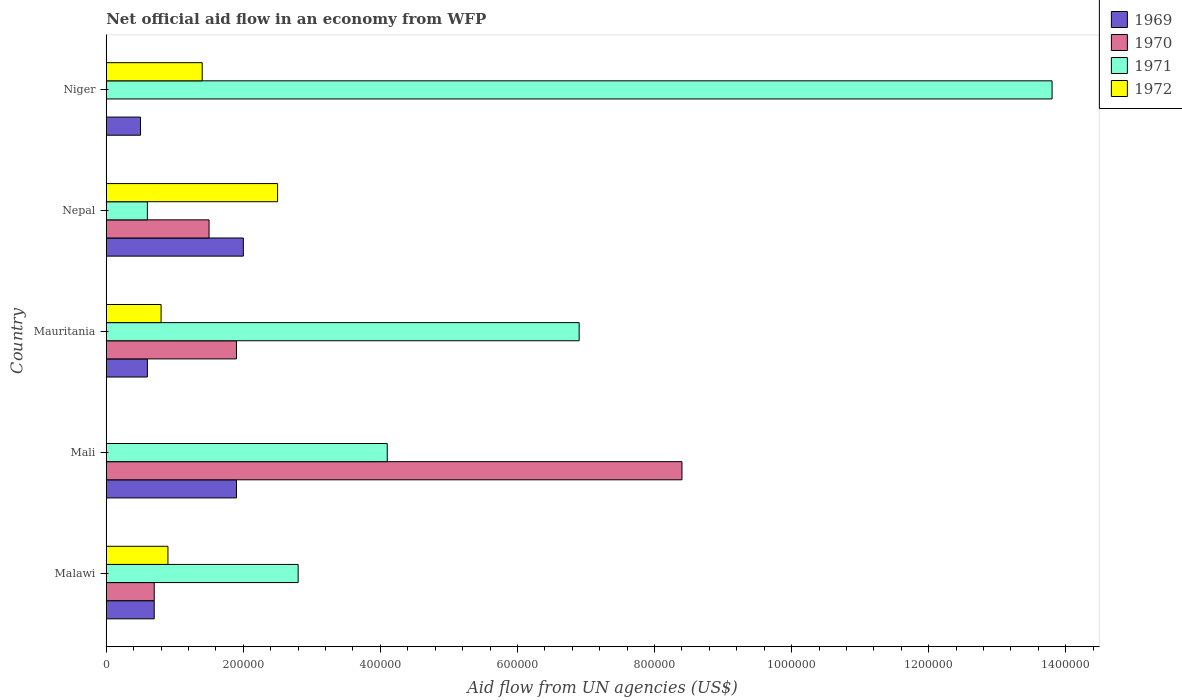How many different coloured bars are there?
Your answer should be very brief. 4. How many groups of bars are there?
Make the answer very short. 5. Are the number of bars per tick equal to the number of legend labels?
Your response must be concise. No. How many bars are there on the 3rd tick from the top?
Provide a succinct answer. 4. How many bars are there on the 3rd tick from the bottom?
Ensure brevity in your answer.  4. What is the label of the 4th group of bars from the top?
Offer a terse response. Mali. In how many cases, is the number of bars for a given country not equal to the number of legend labels?
Provide a short and direct response. 2. Across all countries, what is the maximum net official aid flow in 1971?
Provide a succinct answer. 1.38e+06. Across all countries, what is the minimum net official aid flow in 1972?
Your answer should be very brief. 0. In which country was the net official aid flow in 1970 maximum?
Your response must be concise. Mali. What is the total net official aid flow in 1969 in the graph?
Ensure brevity in your answer.  5.70e+05. What is the difference between the net official aid flow in 1971 in Malawi and that in Niger?
Ensure brevity in your answer.  -1.10e+06. What is the difference between the net official aid flow in 1972 in Mauritania and the net official aid flow in 1969 in Malawi?
Keep it short and to the point. 10000. What is the difference between the net official aid flow in 1970 and net official aid flow in 1972 in Mauritania?
Your response must be concise. 1.10e+05. In how many countries, is the net official aid flow in 1970 greater than 880000 US$?
Make the answer very short. 0. What is the ratio of the net official aid flow in 1971 in Malawi to that in Mali?
Ensure brevity in your answer.  0.68. Is the net official aid flow in 1971 in Mali less than that in Nepal?
Provide a short and direct response. No. What is the difference between the highest and the second highest net official aid flow in 1971?
Your answer should be compact. 6.90e+05. What is the difference between the highest and the lowest net official aid flow in 1970?
Offer a terse response. 8.40e+05. Is the sum of the net official aid flow in 1971 in Mauritania and Nepal greater than the maximum net official aid flow in 1972 across all countries?
Offer a terse response. Yes. Is it the case that in every country, the sum of the net official aid flow in 1971 and net official aid flow in 1970 is greater than the sum of net official aid flow in 1972 and net official aid flow in 1969?
Give a very brief answer. No. How many bars are there?
Ensure brevity in your answer.  18. Are all the bars in the graph horizontal?
Ensure brevity in your answer.  Yes. How many countries are there in the graph?
Give a very brief answer. 5. What is the title of the graph?
Your answer should be compact. Net official aid flow in an economy from WFP. Does "1962" appear as one of the legend labels in the graph?
Ensure brevity in your answer.  No. What is the label or title of the X-axis?
Make the answer very short. Aid flow from UN agencies (US$). What is the Aid flow from UN agencies (US$) of 1969 in Malawi?
Provide a succinct answer. 7.00e+04. What is the Aid flow from UN agencies (US$) of 1971 in Malawi?
Ensure brevity in your answer.  2.80e+05. What is the Aid flow from UN agencies (US$) of 1972 in Malawi?
Provide a succinct answer. 9.00e+04. What is the Aid flow from UN agencies (US$) of 1969 in Mali?
Offer a very short reply. 1.90e+05. What is the Aid flow from UN agencies (US$) in 1970 in Mali?
Make the answer very short. 8.40e+05. What is the Aid flow from UN agencies (US$) in 1971 in Mali?
Your response must be concise. 4.10e+05. What is the Aid flow from UN agencies (US$) in 1970 in Mauritania?
Keep it short and to the point. 1.90e+05. What is the Aid flow from UN agencies (US$) of 1971 in Mauritania?
Make the answer very short. 6.90e+05. What is the Aid flow from UN agencies (US$) in 1972 in Mauritania?
Make the answer very short. 8.00e+04. What is the Aid flow from UN agencies (US$) in 1969 in Nepal?
Give a very brief answer. 2.00e+05. What is the Aid flow from UN agencies (US$) in 1970 in Nepal?
Your answer should be very brief. 1.50e+05. What is the Aid flow from UN agencies (US$) in 1971 in Nepal?
Provide a succinct answer. 6.00e+04. What is the Aid flow from UN agencies (US$) of 1972 in Nepal?
Make the answer very short. 2.50e+05. What is the Aid flow from UN agencies (US$) in 1969 in Niger?
Offer a very short reply. 5.00e+04. What is the Aid flow from UN agencies (US$) of 1970 in Niger?
Offer a very short reply. 0. What is the Aid flow from UN agencies (US$) of 1971 in Niger?
Your answer should be compact. 1.38e+06. Across all countries, what is the maximum Aid flow from UN agencies (US$) of 1969?
Offer a terse response. 2.00e+05. Across all countries, what is the maximum Aid flow from UN agencies (US$) in 1970?
Your answer should be compact. 8.40e+05. Across all countries, what is the maximum Aid flow from UN agencies (US$) of 1971?
Give a very brief answer. 1.38e+06. Across all countries, what is the maximum Aid flow from UN agencies (US$) in 1972?
Give a very brief answer. 2.50e+05. What is the total Aid flow from UN agencies (US$) in 1969 in the graph?
Offer a terse response. 5.70e+05. What is the total Aid flow from UN agencies (US$) of 1970 in the graph?
Provide a short and direct response. 1.25e+06. What is the total Aid flow from UN agencies (US$) in 1971 in the graph?
Provide a short and direct response. 2.82e+06. What is the total Aid flow from UN agencies (US$) in 1972 in the graph?
Your answer should be compact. 5.60e+05. What is the difference between the Aid flow from UN agencies (US$) in 1970 in Malawi and that in Mali?
Offer a very short reply. -7.70e+05. What is the difference between the Aid flow from UN agencies (US$) in 1971 in Malawi and that in Mali?
Provide a succinct answer. -1.30e+05. What is the difference between the Aid flow from UN agencies (US$) in 1971 in Malawi and that in Mauritania?
Your answer should be very brief. -4.10e+05. What is the difference between the Aid flow from UN agencies (US$) of 1971 in Malawi and that in Nepal?
Provide a short and direct response. 2.20e+05. What is the difference between the Aid flow from UN agencies (US$) of 1969 in Malawi and that in Niger?
Your response must be concise. 2.00e+04. What is the difference between the Aid flow from UN agencies (US$) of 1971 in Malawi and that in Niger?
Your answer should be very brief. -1.10e+06. What is the difference between the Aid flow from UN agencies (US$) in 1970 in Mali and that in Mauritania?
Provide a succinct answer. 6.50e+05. What is the difference between the Aid flow from UN agencies (US$) of 1971 in Mali and that in Mauritania?
Make the answer very short. -2.80e+05. What is the difference between the Aid flow from UN agencies (US$) in 1970 in Mali and that in Nepal?
Your answer should be compact. 6.90e+05. What is the difference between the Aid flow from UN agencies (US$) of 1971 in Mali and that in Nepal?
Provide a short and direct response. 3.50e+05. What is the difference between the Aid flow from UN agencies (US$) in 1969 in Mali and that in Niger?
Your response must be concise. 1.40e+05. What is the difference between the Aid flow from UN agencies (US$) in 1971 in Mali and that in Niger?
Keep it short and to the point. -9.70e+05. What is the difference between the Aid flow from UN agencies (US$) in 1971 in Mauritania and that in Nepal?
Keep it short and to the point. 6.30e+05. What is the difference between the Aid flow from UN agencies (US$) in 1969 in Mauritania and that in Niger?
Your answer should be very brief. 10000. What is the difference between the Aid flow from UN agencies (US$) in 1971 in Mauritania and that in Niger?
Give a very brief answer. -6.90e+05. What is the difference between the Aid flow from UN agencies (US$) in 1972 in Mauritania and that in Niger?
Keep it short and to the point. -6.00e+04. What is the difference between the Aid flow from UN agencies (US$) in 1971 in Nepal and that in Niger?
Your answer should be very brief. -1.32e+06. What is the difference between the Aid flow from UN agencies (US$) of 1969 in Malawi and the Aid flow from UN agencies (US$) of 1970 in Mali?
Ensure brevity in your answer.  -7.70e+05. What is the difference between the Aid flow from UN agencies (US$) in 1969 in Malawi and the Aid flow from UN agencies (US$) in 1971 in Mali?
Your answer should be compact. -3.40e+05. What is the difference between the Aid flow from UN agencies (US$) in 1969 in Malawi and the Aid flow from UN agencies (US$) in 1971 in Mauritania?
Provide a short and direct response. -6.20e+05. What is the difference between the Aid flow from UN agencies (US$) of 1970 in Malawi and the Aid flow from UN agencies (US$) of 1971 in Mauritania?
Make the answer very short. -6.20e+05. What is the difference between the Aid flow from UN agencies (US$) in 1970 in Malawi and the Aid flow from UN agencies (US$) in 1972 in Mauritania?
Your answer should be compact. -10000. What is the difference between the Aid flow from UN agencies (US$) in 1969 in Malawi and the Aid flow from UN agencies (US$) in 1970 in Nepal?
Keep it short and to the point. -8.00e+04. What is the difference between the Aid flow from UN agencies (US$) of 1969 in Malawi and the Aid flow from UN agencies (US$) of 1971 in Nepal?
Provide a succinct answer. 10000. What is the difference between the Aid flow from UN agencies (US$) in 1970 in Malawi and the Aid flow from UN agencies (US$) in 1972 in Nepal?
Your answer should be very brief. -1.80e+05. What is the difference between the Aid flow from UN agencies (US$) of 1969 in Malawi and the Aid flow from UN agencies (US$) of 1971 in Niger?
Ensure brevity in your answer.  -1.31e+06. What is the difference between the Aid flow from UN agencies (US$) in 1969 in Malawi and the Aid flow from UN agencies (US$) in 1972 in Niger?
Give a very brief answer. -7.00e+04. What is the difference between the Aid flow from UN agencies (US$) in 1970 in Malawi and the Aid flow from UN agencies (US$) in 1971 in Niger?
Your answer should be very brief. -1.31e+06. What is the difference between the Aid flow from UN agencies (US$) in 1970 in Malawi and the Aid flow from UN agencies (US$) in 1972 in Niger?
Your answer should be compact. -7.00e+04. What is the difference between the Aid flow from UN agencies (US$) in 1969 in Mali and the Aid flow from UN agencies (US$) in 1970 in Mauritania?
Ensure brevity in your answer.  0. What is the difference between the Aid flow from UN agencies (US$) of 1969 in Mali and the Aid flow from UN agencies (US$) of 1971 in Mauritania?
Your response must be concise. -5.00e+05. What is the difference between the Aid flow from UN agencies (US$) of 1970 in Mali and the Aid flow from UN agencies (US$) of 1972 in Mauritania?
Offer a terse response. 7.60e+05. What is the difference between the Aid flow from UN agencies (US$) of 1969 in Mali and the Aid flow from UN agencies (US$) of 1970 in Nepal?
Provide a succinct answer. 4.00e+04. What is the difference between the Aid flow from UN agencies (US$) in 1969 in Mali and the Aid flow from UN agencies (US$) in 1971 in Nepal?
Your answer should be very brief. 1.30e+05. What is the difference between the Aid flow from UN agencies (US$) in 1970 in Mali and the Aid flow from UN agencies (US$) in 1971 in Nepal?
Keep it short and to the point. 7.80e+05. What is the difference between the Aid flow from UN agencies (US$) of 1970 in Mali and the Aid flow from UN agencies (US$) of 1972 in Nepal?
Offer a very short reply. 5.90e+05. What is the difference between the Aid flow from UN agencies (US$) in 1971 in Mali and the Aid flow from UN agencies (US$) in 1972 in Nepal?
Your response must be concise. 1.60e+05. What is the difference between the Aid flow from UN agencies (US$) in 1969 in Mali and the Aid flow from UN agencies (US$) in 1971 in Niger?
Your response must be concise. -1.19e+06. What is the difference between the Aid flow from UN agencies (US$) of 1970 in Mali and the Aid flow from UN agencies (US$) of 1971 in Niger?
Offer a very short reply. -5.40e+05. What is the difference between the Aid flow from UN agencies (US$) of 1970 in Mali and the Aid flow from UN agencies (US$) of 1972 in Niger?
Provide a short and direct response. 7.00e+05. What is the difference between the Aid flow from UN agencies (US$) in 1969 in Mauritania and the Aid flow from UN agencies (US$) in 1970 in Nepal?
Ensure brevity in your answer.  -9.00e+04. What is the difference between the Aid flow from UN agencies (US$) of 1969 in Mauritania and the Aid flow from UN agencies (US$) of 1971 in Nepal?
Your answer should be very brief. 0. What is the difference between the Aid flow from UN agencies (US$) in 1969 in Mauritania and the Aid flow from UN agencies (US$) in 1972 in Nepal?
Your answer should be compact. -1.90e+05. What is the difference between the Aid flow from UN agencies (US$) in 1970 in Mauritania and the Aid flow from UN agencies (US$) in 1972 in Nepal?
Offer a terse response. -6.00e+04. What is the difference between the Aid flow from UN agencies (US$) of 1969 in Mauritania and the Aid flow from UN agencies (US$) of 1971 in Niger?
Offer a very short reply. -1.32e+06. What is the difference between the Aid flow from UN agencies (US$) in 1969 in Mauritania and the Aid flow from UN agencies (US$) in 1972 in Niger?
Your response must be concise. -8.00e+04. What is the difference between the Aid flow from UN agencies (US$) in 1970 in Mauritania and the Aid flow from UN agencies (US$) in 1971 in Niger?
Your answer should be compact. -1.19e+06. What is the difference between the Aid flow from UN agencies (US$) of 1969 in Nepal and the Aid flow from UN agencies (US$) of 1971 in Niger?
Your response must be concise. -1.18e+06. What is the difference between the Aid flow from UN agencies (US$) of 1970 in Nepal and the Aid flow from UN agencies (US$) of 1971 in Niger?
Offer a very short reply. -1.23e+06. What is the difference between the Aid flow from UN agencies (US$) in 1970 in Nepal and the Aid flow from UN agencies (US$) in 1972 in Niger?
Your answer should be compact. 10000. What is the average Aid flow from UN agencies (US$) in 1969 per country?
Your answer should be compact. 1.14e+05. What is the average Aid flow from UN agencies (US$) in 1971 per country?
Your answer should be compact. 5.64e+05. What is the average Aid flow from UN agencies (US$) of 1972 per country?
Give a very brief answer. 1.12e+05. What is the difference between the Aid flow from UN agencies (US$) in 1969 and Aid flow from UN agencies (US$) in 1970 in Malawi?
Your response must be concise. 0. What is the difference between the Aid flow from UN agencies (US$) in 1969 and Aid flow from UN agencies (US$) in 1971 in Malawi?
Provide a succinct answer. -2.10e+05. What is the difference between the Aid flow from UN agencies (US$) of 1969 and Aid flow from UN agencies (US$) of 1972 in Malawi?
Offer a terse response. -2.00e+04. What is the difference between the Aid flow from UN agencies (US$) of 1969 and Aid flow from UN agencies (US$) of 1970 in Mali?
Keep it short and to the point. -6.50e+05. What is the difference between the Aid flow from UN agencies (US$) of 1970 and Aid flow from UN agencies (US$) of 1971 in Mali?
Offer a terse response. 4.30e+05. What is the difference between the Aid flow from UN agencies (US$) in 1969 and Aid flow from UN agencies (US$) in 1970 in Mauritania?
Your answer should be very brief. -1.30e+05. What is the difference between the Aid flow from UN agencies (US$) of 1969 and Aid flow from UN agencies (US$) of 1971 in Mauritania?
Offer a very short reply. -6.30e+05. What is the difference between the Aid flow from UN agencies (US$) in 1969 and Aid flow from UN agencies (US$) in 1972 in Mauritania?
Your answer should be compact. -2.00e+04. What is the difference between the Aid flow from UN agencies (US$) in 1970 and Aid flow from UN agencies (US$) in 1971 in Mauritania?
Provide a short and direct response. -5.00e+05. What is the difference between the Aid flow from UN agencies (US$) in 1970 and Aid flow from UN agencies (US$) in 1972 in Mauritania?
Keep it short and to the point. 1.10e+05. What is the difference between the Aid flow from UN agencies (US$) of 1969 and Aid flow from UN agencies (US$) of 1972 in Nepal?
Give a very brief answer. -5.00e+04. What is the difference between the Aid flow from UN agencies (US$) in 1969 and Aid flow from UN agencies (US$) in 1971 in Niger?
Keep it short and to the point. -1.33e+06. What is the difference between the Aid flow from UN agencies (US$) in 1971 and Aid flow from UN agencies (US$) in 1972 in Niger?
Keep it short and to the point. 1.24e+06. What is the ratio of the Aid flow from UN agencies (US$) in 1969 in Malawi to that in Mali?
Offer a very short reply. 0.37. What is the ratio of the Aid flow from UN agencies (US$) of 1970 in Malawi to that in Mali?
Make the answer very short. 0.08. What is the ratio of the Aid flow from UN agencies (US$) of 1971 in Malawi to that in Mali?
Keep it short and to the point. 0.68. What is the ratio of the Aid flow from UN agencies (US$) of 1969 in Malawi to that in Mauritania?
Make the answer very short. 1.17. What is the ratio of the Aid flow from UN agencies (US$) in 1970 in Malawi to that in Mauritania?
Your response must be concise. 0.37. What is the ratio of the Aid flow from UN agencies (US$) of 1971 in Malawi to that in Mauritania?
Keep it short and to the point. 0.41. What is the ratio of the Aid flow from UN agencies (US$) of 1972 in Malawi to that in Mauritania?
Offer a terse response. 1.12. What is the ratio of the Aid flow from UN agencies (US$) of 1969 in Malawi to that in Nepal?
Ensure brevity in your answer.  0.35. What is the ratio of the Aid flow from UN agencies (US$) of 1970 in Malawi to that in Nepal?
Provide a succinct answer. 0.47. What is the ratio of the Aid flow from UN agencies (US$) of 1971 in Malawi to that in Nepal?
Provide a short and direct response. 4.67. What is the ratio of the Aid flow from UN agencies (US$) of 1972 in Malawi to that in Nepal?
Offer a very short reply. 0.36. What is the ratio of the Aid flow from UN agencies (US$) of 1971 in Malawi to that in Niger?
Your answer should be very brief. 0.2. What is the ratio of the Aid flow from UN agencies (US$) in 1972 in Malawi to that in Niger?
Offer a terse response. 0.64. What is the ratio of the Aid flow from UN agencies (US$) of 1969 in Mali to that in Mauritania?
Your response must be concise. 3.17. What is the ratio of the Aid flow from UN agencies (US$) in 1970 in Mali to that in Mauritania?
Offer a very short reply. 4.42. What is the ratio of the Aid flow from UN agencies (US$) in 1971 in Mali to that in Mauritania?
Offer a terse response. 0.59. What is the ratio of the Aid flow from UN agencies (US$) of 1971 in Mali to that in Nepal?
Offer a terse response. 6.83. What is the ratio of the Aid flow from UN agencies (US$) in 1969 in Mali to that in Niger?
Offer a very short reply. 3.8. What is the ratio of the Aid flow from UN agencies (US$) in 1971 in Mali to that in Niger?
Provide a succinct answer. 0.3. What is the ratio of the Aid flow from UN agencies (US$) in 1969 in Mauritania to that in Nepal?
Provide a succinct answer. 0.3. What is the ratio of the Aid flow from UN agencies (US$) in 1970 in Mauritania to that in Nepal?
Your response must be concise. 1.27. What is the ratio of the Aid flow from UN agencies (US$) of 1972 in Mauritania to that in Nepal?
Your response must be concise. 0.32. What is the ratio of the Aid flow from UN agencies (US$) in 1972 in Mauritania to that in Niger?
Offer a terse response. 0.57. What is the ratio of the Aid flow from UN agencies (US$) in 1971 in Nepal to that in Niger?
Provide a short and direct response. 0.04. What is the ratio of the Aid flow from UN agencies (US$) in 1972 in Nepal to that in Niger?
Provide a succinct answer. 1.79. What is the difference between the highest and the second highest Aid flow from UN agencies (US$) in 1969?
Make the answer very short. 10000. What is the difference between the highest and the second highest Aid flow from UN agencies (US$) of 1970?
Your response must be concise. 6.50e+05. What is the difference between the highest and the second highest Aid flow from UN agencies (US$) in 1971?
Your response must be concise. 6.90e+05. What is the difference between the highest and the second highest Aid flow from UN agencies (US$) in 1972?
Your answer should be very brief. 1.10e+05. What is the difference between the highest and the lowest Aid flow from UN agencies (US$) of 1969?
Keep it short and to the point. 1.50e+05. What is the difference between the highest and the lowest Aid flow from UN agencies (US$) of 1970?
Give a very brief answer. 8.40e+05. What is the difference between the highest and the lowest Aid flow from UN agencies (US$) of 1971?
Your answer should be compact. 1.32e+06. 